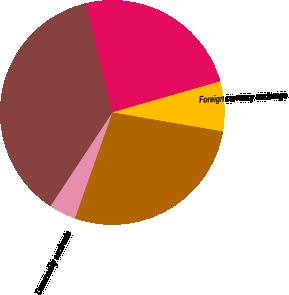Convert chart. <chart><loc_0><loc_0><loc_500><loc_500><pie_chart><fcel>(millions)<fcel>Foreign currency exchange<fcel>Interest rate contracts<fcel>Commodity contracts<fcel>Total<nl><fcel>24.39%<fcel>7.18%<fcel>27.69%<fcel>3.88%<fcel>36.86%<nl></chart> 